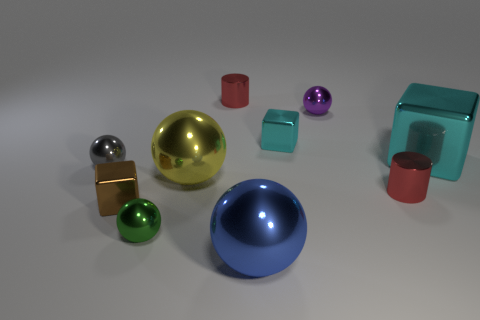Is the number of small red cylinders less than the number of blue rubber cylinders?
Give a very brief answer. No. Does the small cube that is behind the big block have the same color as the big metallic block?
Offer a terse response. Yes. What number of red cylinders are in front of the tiny metal cube in front of the small shiny block to the right of the brown shiny object?
Provide a succinct answer. 0. There is a tiny gray thing; how many balls are on the left side of it?
Offer a terse response. 0. The large thing that is the same shape as the tiny brown shiny object is what color?
Keep it short and to the point. Cyan. There is a ball that is behind the gray sphere; does it have the same size as the small green shiny ball?
Your answer should be compact. Yes. What material is the large yellow ball?
Your answer should be compact. Metal. What is the color of the tiny cube right of the tiny brown metal cube?
Your answer should be compact. Cyan. How many tiny things are gray shiny cubes or spheres?
Your answer should be compact. 3. There is a tiny block that is to the right of the tiny green thing; is its color the same as the big metallic thing behind the tiny gray metal sphere?
Your response must be concise. Yes. 